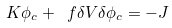Convert formula to latex. <formula><loc_0><loc_0><loc_500><loc_500>K \phi _ { c } + \ f { \delta V } { \delta \phi _ { c } } = - J</formula> 